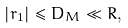Convert formula to latex. <formula><loc_0><loc_0><loc_500><loc_500>| r _ { 1 } | \leq D _ { M } \ll R ,</formula> 